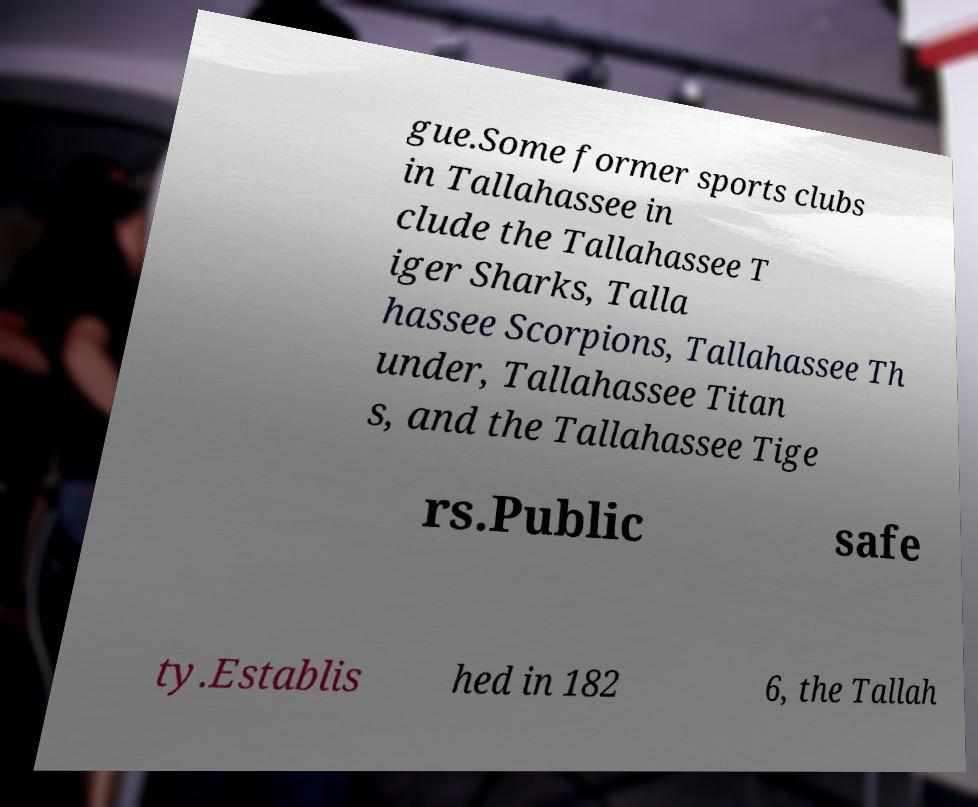I need the written content from this picture converted into text. Can you do that? gue.Some former sports clubs in Tallahassee in clude the Tallahassee T iger Sharks, Talla hassee Scorpions, Tallahassee Th under, Tallahassee Titan s, and the Tallahassee Tige rs.Public safe ty.Establis hed in 182 6, the Tallah 